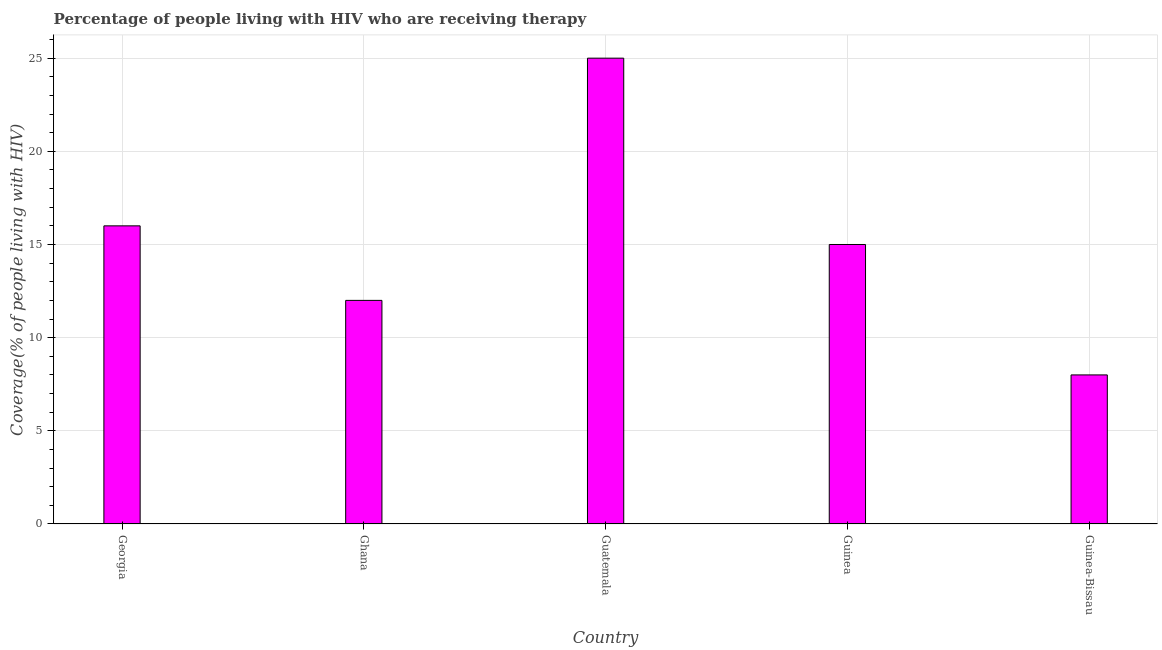What is the title of the graph?
Your response must be concise. Percentage of people living with HIV who are receiving therapy. What is the label or title of the Y-axis?
Provide a short and direct response. Coverage(% of people living with HIV). Across all countries, what is the minimum antiretroviral therapy coverage?
Your answer should be very brief. 8. In which country was the antiretroviral therapy coverage maximum?
Your response must be concise. Guatemala. In which country was the antiretroviral therapy coverage minimum?
Provide a succinct answer. Guinea-Bissau. What is the difference between the antiretroviral therapy coverage in Ghana and Guinea?
Ensure brevity in your answer.  -3. What is the average antiretroviral therapy coverage per country?
Offer a terse response. 15.2. In how many countries, is the antiretroviral therapy coverage greater than 3 %?
Your answer should be very brief. 5. Is the antiretroviral therapy coverage in Ghana less than that in Guinea?
Offer a very short reply. Yes. Is the difference between the antiretroviral therapy coverage in Ghana and Guinea-Bissau greater than the difference between any two countries?
Offer a terse response. No. In how many countries, is the antiretroviral therapy coverage greater than the average antiretroviral therapy coverage taken over all countries?
Offer a terse response. 2. How many bars are there?
Ensure brevity in your answer.  5. What is the Coverage(% of people living with HIV) in Georgia?
Provide a succinct answer. 16. What is the Coverage(% of people living with HIV) of Guinea-Bissau?
Make the answer very short. 8. What is the difference between the Coverage(% of people living with HIV) in Georgia and Ghana?
Your response must be concise. 4. What is the difference between the Coverage(% of people living with HIV) in Georgia and Guatemala?
Your answer should be very brief. -9. What is the difference between the Coverage(% of people living with HIV) in Georgia and Guinea?
Offer a very short reply. 1. What is the difference between the Coverage(% of people living with HIV) in Ghana and Guinea-Bissau?
Your answer should be compact. 4. What is the difference between the Coverage(% of people living with HIV) in Guatemala and Guinea?
Keep it short and to the point. 10. What is the difference between the Coverage(% of people living with HIV) in Guatemala and Guinea-Bissau?
Your answer should be compact. 17. What is the ratio of the Coverage(% of people living with HIV) in Georgia to that in Ghana?
Offer a terse response. 1.33. What is the ratio of the Coverage(% of people living with HIV) in Georgia to that in Guatemala?
Provide a succinct answer. 0.64. What is the ratio of the Coverage(% of people living with HIV) in Georgia to that in Guinea?
Your answer should be compact. 1.07. What is the ratio of the Coverage(% of people living with HIV) in Georgia to that in Guinea-Bissau?
Give a very brief answer. 2. What is the ratio of the Coverage(% of people living with HIV) in Ghana to that in Guatemala?
Offer a terse response. 0.48. What is the ratio of the Coverage(% of people living with HIV) in Ghana to that in Guinea?
Ensure brevity in your answer.  0.8. What is the ratio of the Coverage(% of people living with HIV) in Ghana to that in Guinea-Bissau?
Make the answer very short. 1.5. What is the ratio of the Coverage(% of people living with HIV) in Guatemala to that in Guinea?
Provide a short and direct response. 1.67. What is the ratio of the Coverage(% of people living with HIV) in Guatemala to that in Guinea-Bissau?
Your answer should be compact. 3.12. What is the ratio of the Coverage(% of people living with HIV) in Guinea to that in Guinea-Bissau?
Make the answer very short. 1.88. 